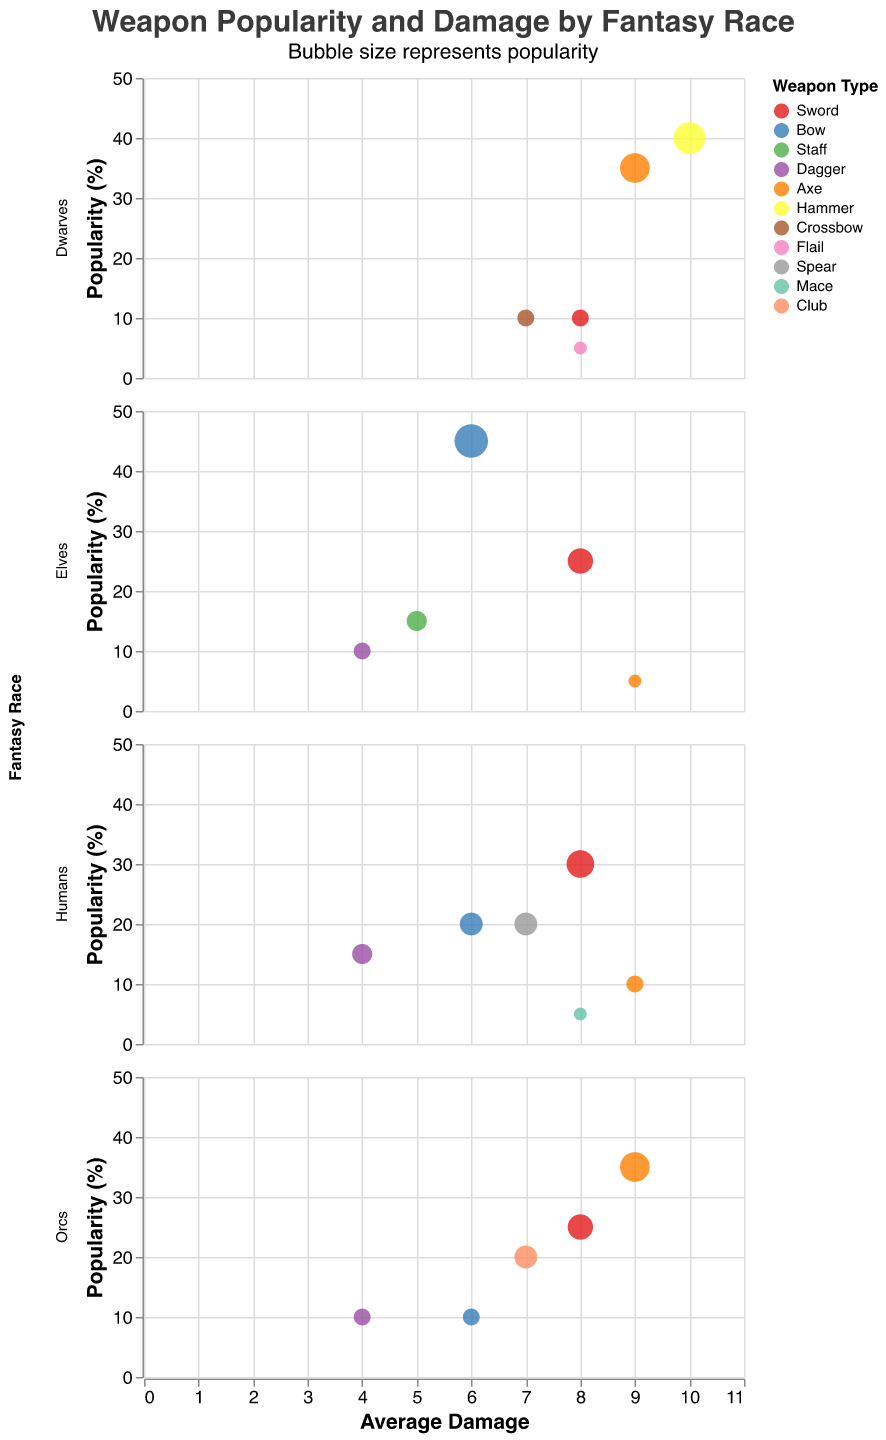What is the most popular weapon type among Elves? From the subplot for Elves, look at the y-axis (Popularity (%)) for each weapon type. The Bow has the highest y-value at 45.
Answer: Bow What race favors the Axe the most? Compare the popularity of Axe across all races by looking at the y-axis values for Axe bubbles. Orcs have the highest popularity with a 35% rate.
Answer: Orcs Which race has the weapon with the highest average damage? Review the x-axis values (Average Damage) for each weapon across all races. The Hammer used by Dwarves has the highest damage value of 10.
Answer: Dwarves How popular is the Sword among Dwarves compared to Elves? Compare the y-axis values of Sword for Dwarves and Elves. The Sword has a 10% popularity among Dwarves and 25% among Elves.
Answer: Less popular among Dwarves Which race uses the least popular weapon, and what is it? Identify the smallest bubbles (least y-axis value) across all plots. Elves use the Axe with a popularity of 5%, which is the smallest.
Answer: Elves, Axe How does the popularity of Hammer among Dwarves compare to the popularity of Staff among Elves? Look at the y-values of Hammer for Dwarves (40%) and Staff for Elves (15%). Hammer is more popular.
Answer: Hammer is more popular Which weapon type is equally popular among Humans and Orcs, and what is its popularity? Compare the y-values across all weapon types for Humans and Orcs. The Dagger is equally popular, both at 10%.
Answer: Dagger, 10% What is the average popularity of the Sword among all races? Sum the popularity values of Sword for Elves (25%), Dwarves (10%), Humans (30%), and Orcs (25%), then divide by 4. The sum is 90, and the average is 90/4 = 22.5.
Answer: 22.5% Which race has the widest variety of weapon types? Count the number of unique weapon types per race plot. Humans use 6 different weapons (Sword, Spear, Bow, Dagger, Axe, Mace).
Answer: Humans 